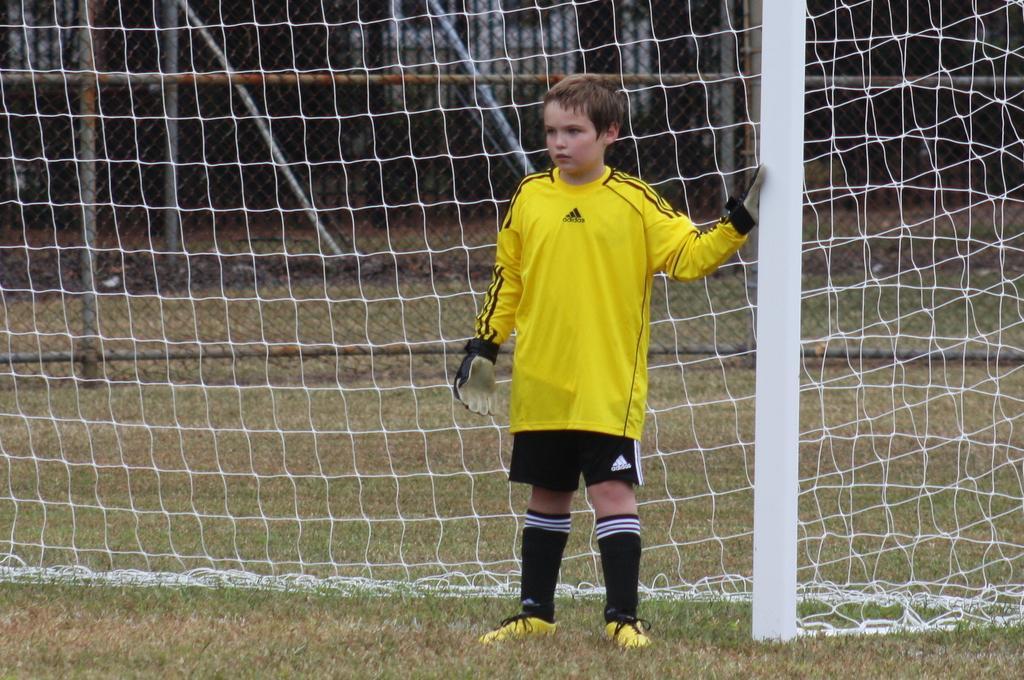Describe this image in one or two sentences. In this image there is a kid standing in front of a goal post. 